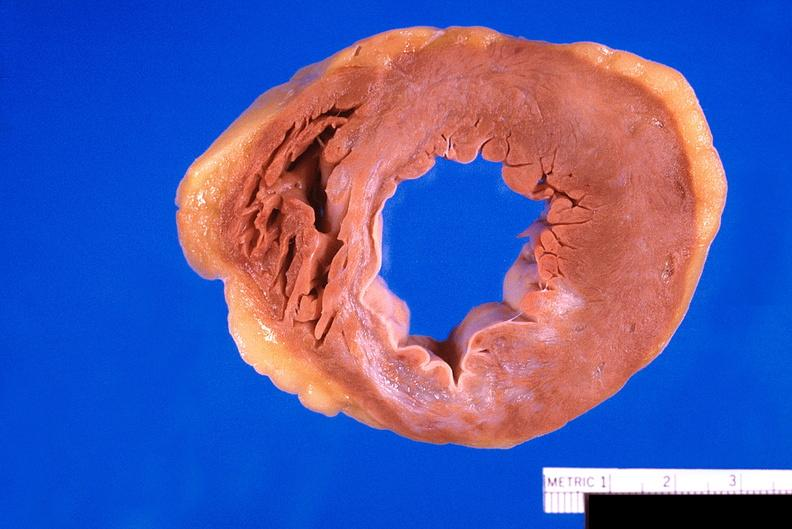s cardiovascular present?
Answer the question using a single word or phrase. Yes 